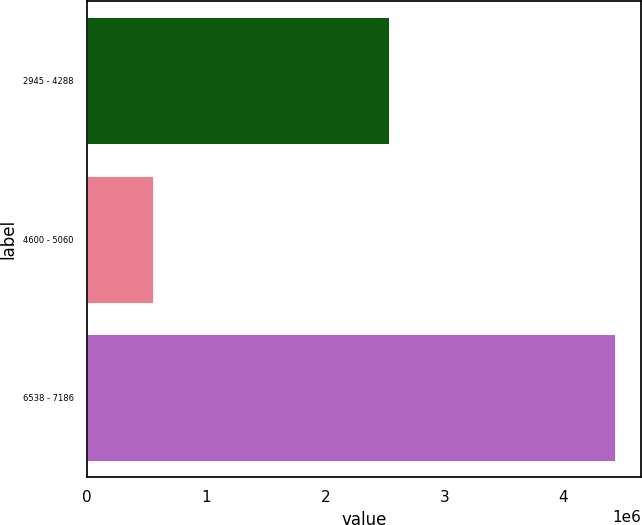Convert chart to OTSL. <chart><loc_0><loc_0><loc_500><loc_500><bar_chart><fcel>2945 - 4288<fcel>4600 - 5060<fcel>6538 - 7186<nl><fcel>2.53572e+06<fcel>552000<fcel>4.43304e+06<nl></chart> 